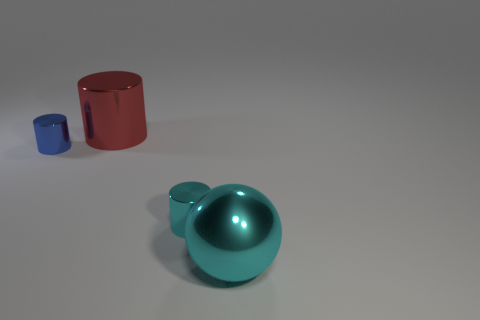Add 1 large gray things. How many objects exist? 5 Subtract all balls. How many objects are left? 3 Subtract 0 green cylinders. How many objects are left? 4 Subtract all tiny rubber cubes. Subtract all cyan metal things. How many objects are left? 2 Add 2 big metal things. How many big metal things are left? 4 Add 4 red metallic cylinders. How many red metallic cylinders exist? 5 